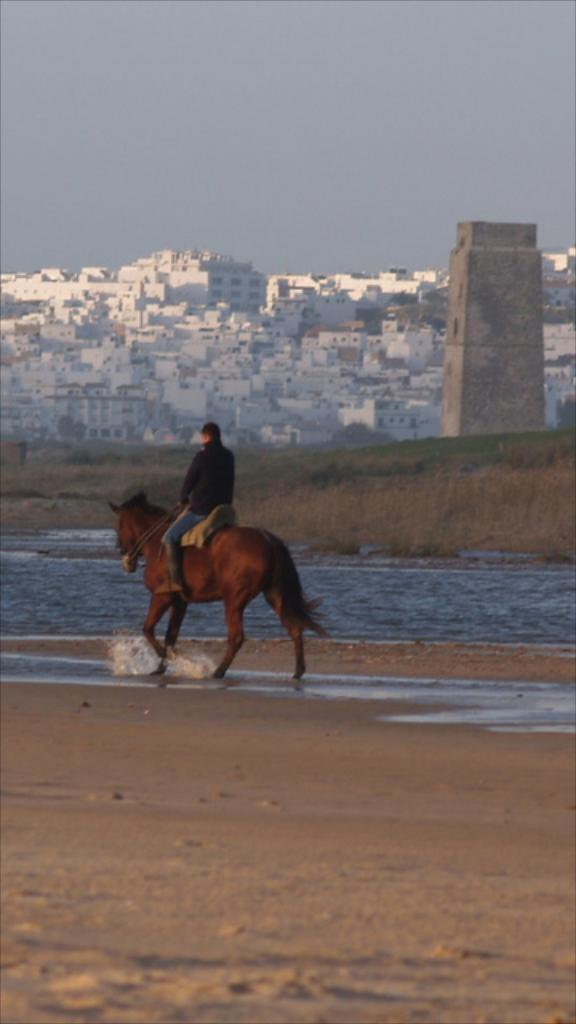What is the main subject of the image? There is a person riding a horse in the image. Where is the horse located? The horse is on a wetland. What can be seen in the background of the image? There is water, a tower, buildings on a mountain, and the sky visible in the background of the image. How many kittens are playing with a quill in the image? There are no kittens or quills present in the image. What type of drug is being administered to the horse in the image? There is no drug being administered to the horse in the image. 